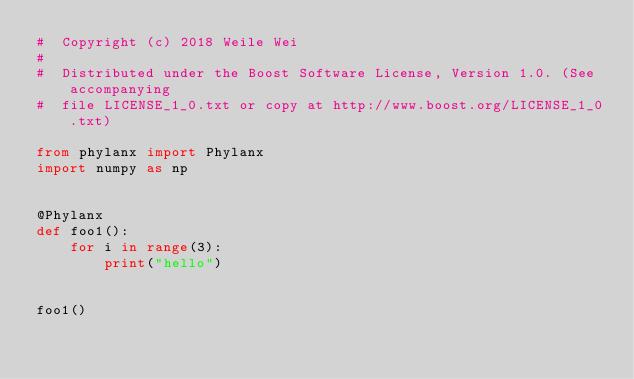Convert code to text. <code><loc_0><loc_0><loc_500><loc_500><_Python_>#  Copyright (c) 2018 Weile Wei
#
#  Distributed under the Boost Software License, Version 1.0. (See accompanying
#  file LICENSE_1_0.txt or copy at http://www.boost.org/LICENSE_1_0.txt)

from phylanx import Phylanx
import numpy as np


@Phylanx
def foo1():
    for i in range(3):
        print("hello")


foo1()
</code> 